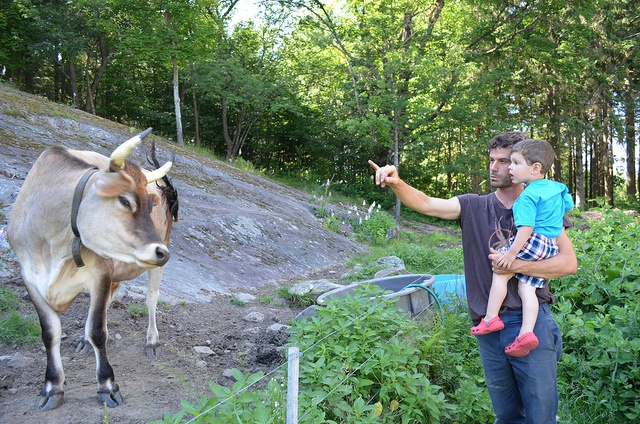Describe the objects in this image and their specific colors. I can see cow in black, darkgray, lightgray, and gray tones, people in black, gray, navy, and blue tones, and people in black, lavender, cyan, lightpink, and gray tones in this image. 